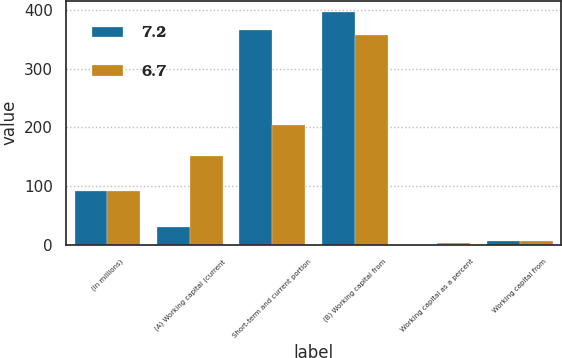Convert chart. <chart><loc_0><loc_0><loc_500><loc_500><stacked_bar_chart><ecel><fcel>(In millions)<fcel>(A) Working capital (current<fcel>Short-term and current portion<fcel>(B) Working capital from<fcel>Working capital as a percent<fcel>Working capital from<nl><fcel>7.2<fcel>91.4<fcel>31<fcel>364.7<fcel>395.7<fcel>0.6<fcel>7.2<nl><fcel>6.7<fcel>91.4<fcel>151.8<fcel>204.5<fcel>356.3<fcel>2.9<fcel>6.7<nl></chart> 